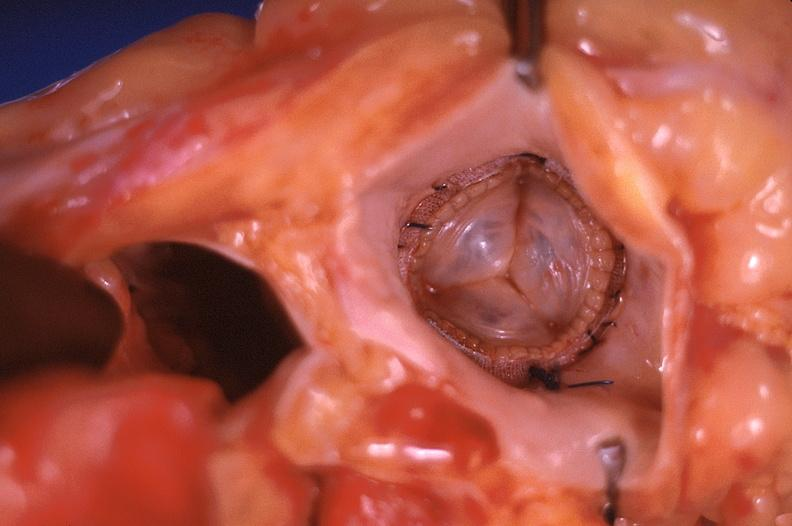does this image show prosthetic mitral valve, carpentier-edwards valve bovine pericardial bioprosthesis?
Answer the question using a single word or phrase. Yes 